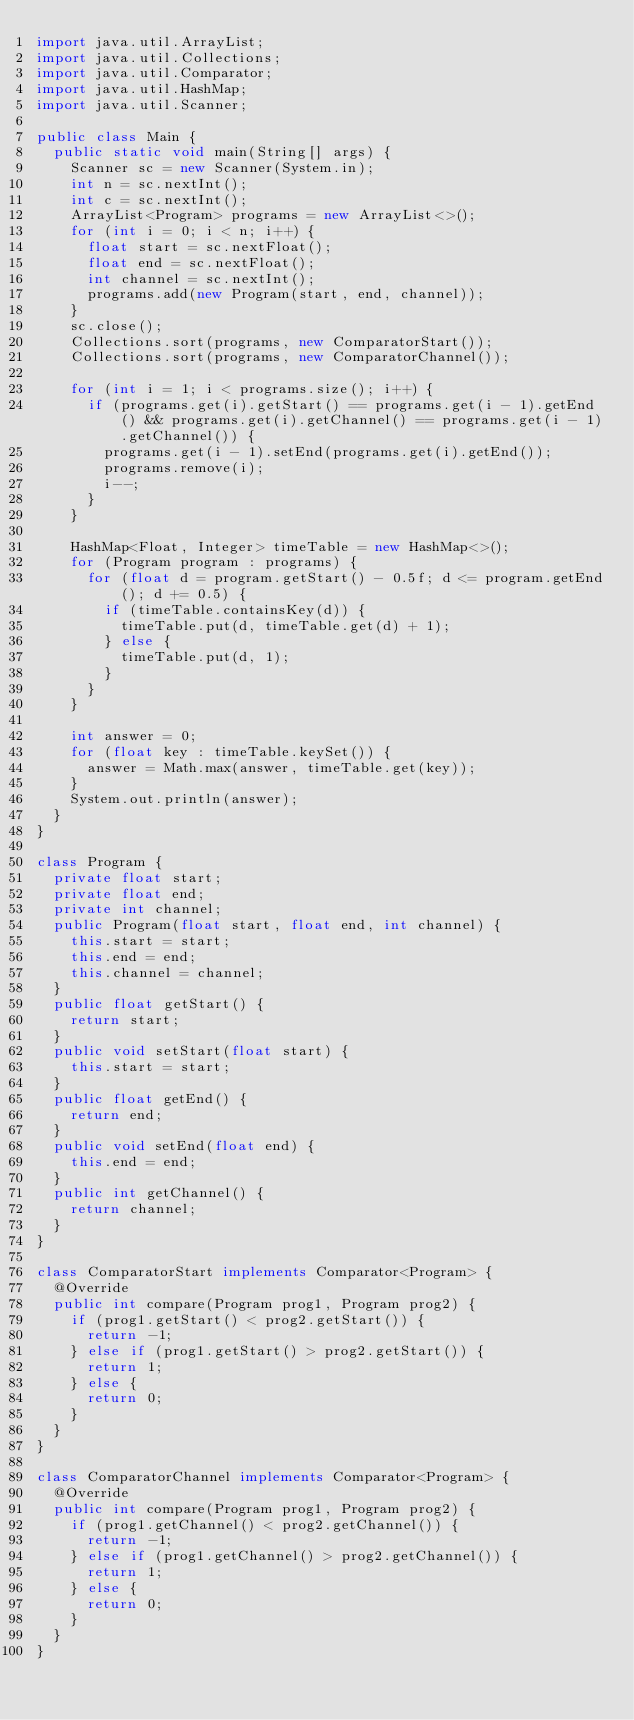<code> <loc_0><loc_0><loc_500><loc_500><_Java_>import java.util.ArrayList;
import java.util.Collections;
import java.util.Comparator;
import java.util.HashMap;
import java.util.Scanner;

public class Main {
	public static void main(String[] args) {
		Scanner sc = new Scanner(System.in);
		int n = sc.nextInt();
		int c = sc.nextInt();
		ArrayList<Program> programs = new ArrayList<>();
		for (int i = 0; i < n; i++) {
			float start = sc.nextFloat();
			float end = sc.nextFloat();
			int channel = sc.nextInt();
			programs.add(new Program(start, end, channel));
		}
		sc.close();
		Collections.sort(programs, new ComparatorStart());
		Collections.sort(programs, new ComparatorChannel());

		for (int i = 1; i < programs.size(); i++) {
			if (programs.get(i).getStart() == programs.get(i - 1).getEnd() && programs.get(i).getChannel() == programs.get(i - 1).getChannel()) {
				programs.get(i - 1).setEnd(programs.get(i).getEnd());
				programs.remove(i);
				i--;
			}
		}

		HashMap<Float, Integer> timeTable = new HashMap<>();
		for (Program program : programs) {
			for (float d = program.getStart() - 0.5f; d <= program.getEnd(); d += 0.5) {
				if (timeTable.containsKey(d)) {
					timeTable.put(d, timeTable.get(d) + 1);
				} else {
					timeTable.put(d, 1);
				}
			}
		}

		int answer = 0;
		for (float key : timeTable.keySet()) {
			answer = Math.max(answer, timeTable.get(key));
		}
		System.out.println(answer);
	}
}

class Program {
	private float start;
	private float end;
	private int channel;
	public Program(float start, float end, int channel) {
		this.start = start;
		this.end = end;
		this.channel = channel;
	}
	public float getStart() {
		return start;
	}
	public void setStart(float start) {
		this.start = start;
	}
	public float getEnd() {
		return end;
	}
	public void setEnd(float end) {
		this.end = end;
	}
	public int getChannel() {
		return channel;
	}
}

class ComparatorStart implements Comparator<Program> {
	@Override
	public int compare(Program prog1, Program prog2) {
		if (prog1.getStart() < prog2.getStart()) {
			return -1;
		} else if (prog1.getStart() > prog2.getStart()) {
			return 1;
		} else {
			return 0;
		}
	}
}

class ComparatorChannel implements Comparator<Program> {
	@Override
	public int compare(Program prog1, Program prog2) {
		if (prog1.getChannel() < prog2.getChannel()) {
			return -1;
		} else if (prog1.getChannel() > prog2.getChannel()) {
			return 1;
		} else {
			return 0;
		}
	}
}</code> 